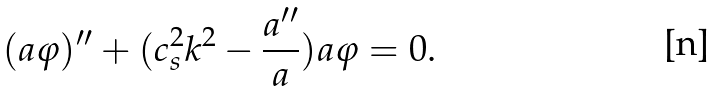Convert formula to latex. <formula><loc_0><loc_0><loc_500><loc_500>( a \varphi ) ^ { \prime \prime } + ( c _ { s } ^ { 2 } k ^ { 2 } - \frac { a ^ { \prime \prime } } { a } ) a \varphi = 0 .</formula> 